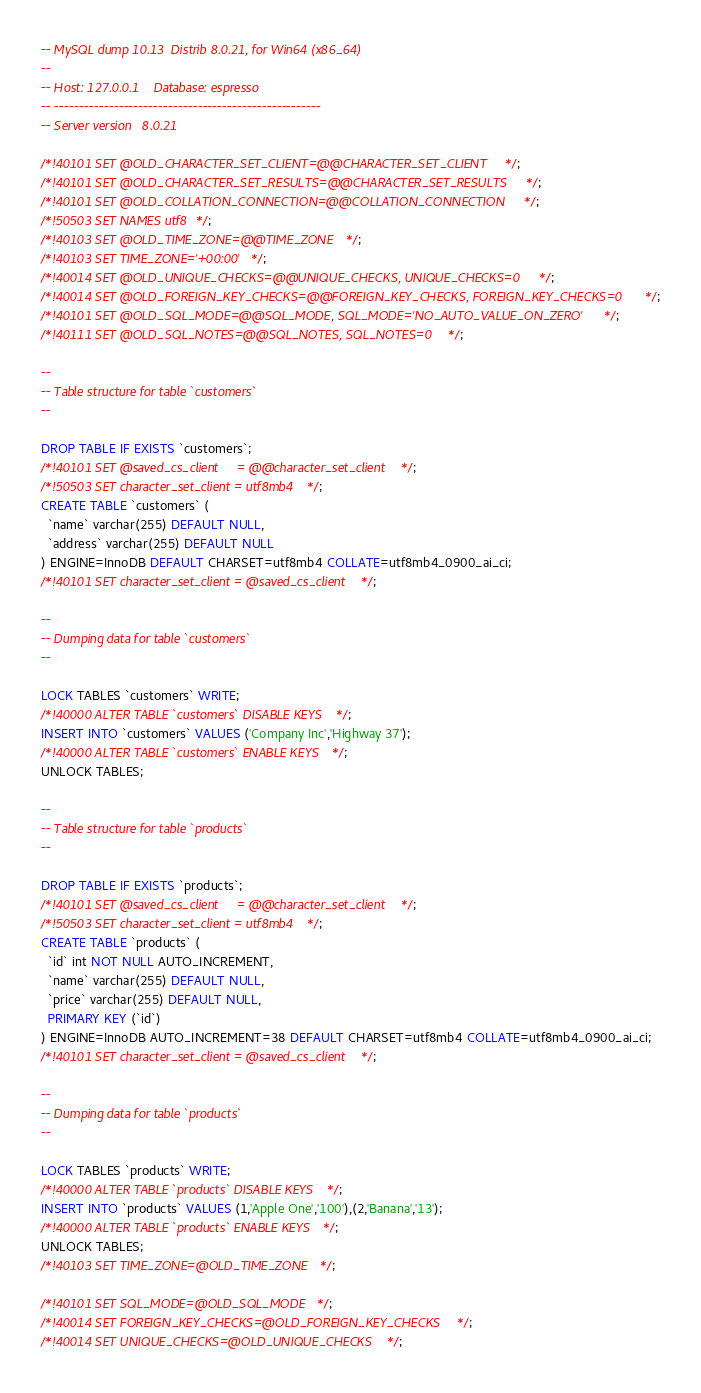Convert code to text. <code><loc_0><loc_0><loc_500><loc_500><_SQL_>-- MySQL dump 10.13  Distrib 8.0.21, for Win64 (x86_64)
--
-- Host: 127.0.0.1    Database: espresso
-- ------------------------------------------------------
-- Server version	8.0.21

/*!40101 SET @OLD_CHARACTER_SET_CLIENT=@@CHARACTER_SET_CLIENT */;
/*!40101 SET @OLD_CHARACTER_SET_RESULTS=@@CHARACTER_SET_RESULTS */;
/*!40101 SET @OLD_COLLATION_CONNECTION=@@COLLATION_CONNECTION */;
/*!50503 SET NAMES utf8 */;
/*!40103 SET @OLD_TIME_ZONE=@@TIME_ZONE */;
/*!40103 SET TIME_ZONE='+00:00' */;
/*!40014 SET @OLD_UNIQUE_CHECKS=@@UNIQUE_CHECKS, UNIQUE_CHECKS=0 */;
/*!40014 SET @OLD_FOREIGN_KEY_CHECKS=@@FOREIGN_KEY_CHECKS, FOREIGN_KEY_CHECKS=0 */;
/*!40101 SET @OLD_SQL_MODE=@@SQL_MODE, SQL_MODE='NO_AUTO_VALUE_ON_ZERO' */;
/*!40111 SET @OLD_SQL_NOTES=@@SQL_NOTES, SQL_NOTES=0 */;

--
-- Table structure for table `customers`
--

DROP TABLE IF EXISTS `customers`;
/*!40101 SET @saved_cs_client     = @@character_set_client */;
/*!50503 SET character_set_client = utf8mb4 */;
CREATE TABLE `customers` (
  `name` varchar(255) DEFAULT NULL,
  `address` varchar(255) DEFAULT NULL
) ENGINE=InnoDB DEFAULT CHARSET=utf8mb4 COLLATE=utf8mb4_0900_ai_ci;
/*!40101 SET character_set_client = @saved_cs_client */;

--
-- Dumping data for table `customers`
--

LOCK TABLES `customers` WRITE;
/*!40000 ALTER TABLE `customers` DISABLE KEYS */;
INSERT INTO `customers` VALUES ('Company Inc','Highway 37');
/*!40000 ALTER TABLE `customers` ENABLE KEYS */;
UNLOCK TABLES;

--
-- Table structure for table `products`
--

DROP TABLE IF EXISTS `products`;
/*!40101 SET @saved_cs_client     = @@character_set_client */;
/*!50503 SET character_set_client = utf8mb4 */;
CREATE TABLE `products` (
  `id` int NOT NULL AUTO_INCREMENT,
  `name` varchar(255) DEFAULT NULL,
  `price` varchar(255) DEFAULT NULL,
  PRIMARY KEY (`id`)
) ENGINE=InnoDB AUTO_INCREMENT=38 DEFAULT CHARSET=utf8mb4 COLLATE=utf8mb4_0900_ai_ci;
/*!40101 SET character_set_client = @saved_cs_client */;

--
-- Dumping data for table `products`
--

LOCK TABLES `products` WRITE;
/*!40000 ALTER TABLE `products` DISABLE KEYS */;
INSERT INTO `products` VALUES (1,'Apple One','100'),(2,'Banana','13');
/*!40000 ALTER TABLE `products` ENABLE KEYS */;
UNLOCK TABLES;
/*!40103 SET TIME_ZONE=@OLD_TIME_ZONE */;

/*!40101 SET SQL_MODE=@OLD_SQL_MODE */;
/*!40014 SET FOREIGN_KEY_CHECKS=@OLD_FOREIGN_KEY_CHECKS */;
/*!40014 SET UNIQUE_CHECKS=@OLD_UNIQUE_CHECKS */;</code> 